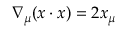<formula> <loc_0><loc_0><loc_500><loc_500>\nabla _ { \mu } ( x \cdot x ) = 2 x _ { \mu }</formula> 